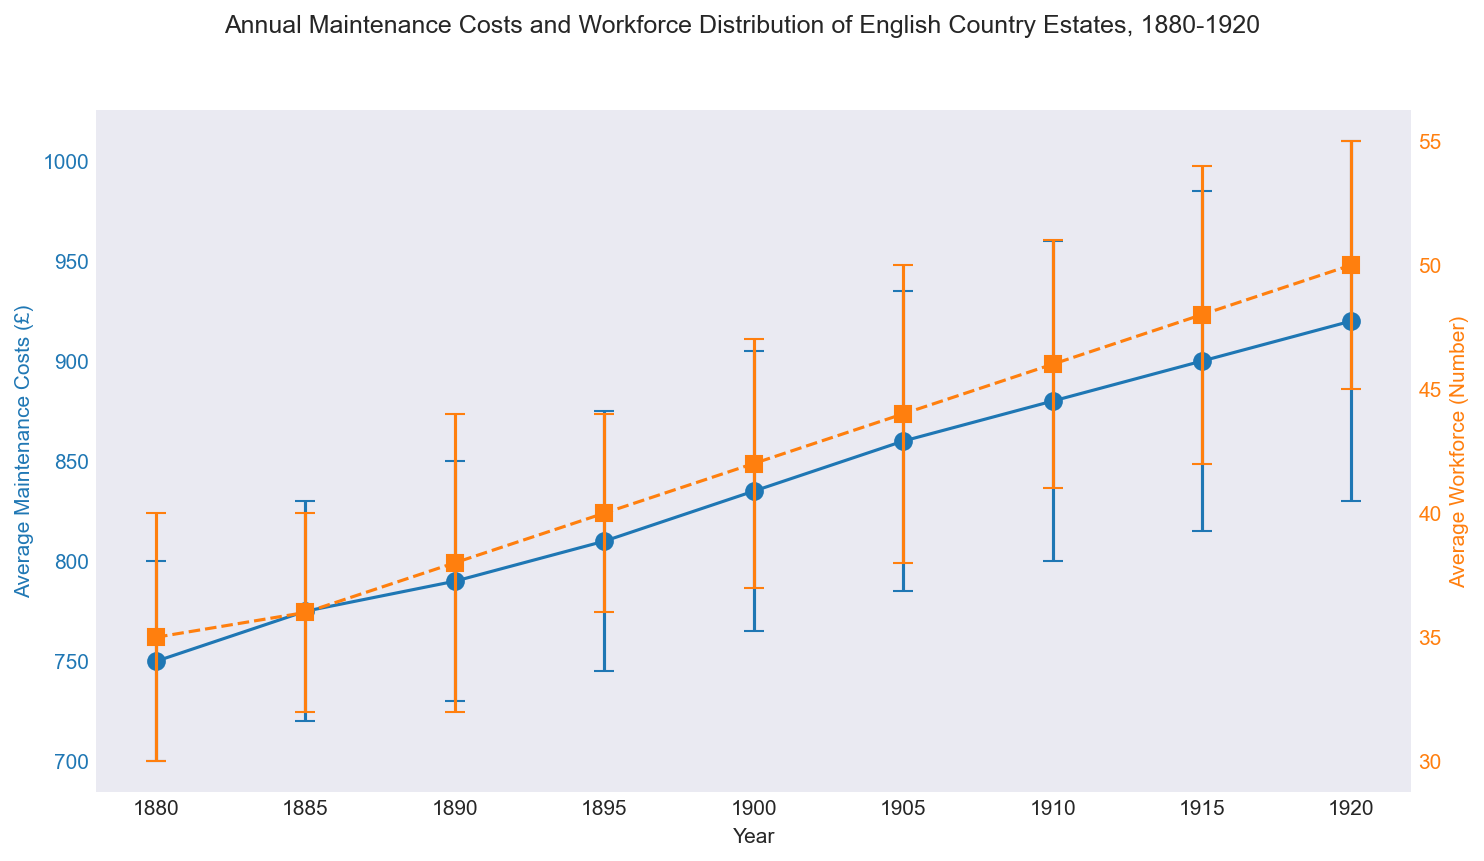What is the trend in the average maintenance costs of English country estates from 1880 to 1920? The average maintenance costs increase over time from £750 in 1880 to £920 in 1920.
Answer: They increase Between which years does the average workforce see the highest increase? The average workforce sees the highest increase between 1915 and 1920, from 48 to 50.
Answer: 1915 to 1920 What is the average of the average maintenance costs over the period 1880-1920? Adding the average maintenance costs from 1880 to 1920: (750 + 775 + 790 + 810 + 835 + 860 + 880 + 900 + 920) = 7520. Divide by the number of years (9) to get 7520/9 ≈ 835.56.
Answer: Approx 835.56 How does the error margin for maintenance costs change over the years? The error margin for maintenance costs gradually increases from £50 in 1880 to £90 in 1920.
Answer: It increases What is the difference between the highest and lowest average workforce over the period? The highest average workforce is 50 in 1920 and the lowest is 35 in 1880. The difference is 50 - 35 = 15.
Answer: 15 In which year is the average maintenance cost the closest to £800? The closest average maintenance cost to £800 is in 1895 (£810).
Answer: 1895 Compare the increase in error margins for maintenance costs and workforce between 1880 and 1920. Which one has a greater increase? The error margin for maintenance costs increases from £50 to £90 (40), and for workforce it increases from 5 to 5 (0). The error margin for maintenance costs has a greater increase.
Answer: Maintenance costs Between 1910 and 1915, how much do the average maintenance costs increase? The average maintenance costs increase from £880 in 1910 to £900 in 1915, an increase of £20.
Answer: £20 Which year has the highest average workforce, and what is the value? The year 1920 has the highest average workforce of 50.
Answer: 1920 In which year did the error margin for workforce show the highest value, and what is that value? The error margin for workforce is highest in two years: 1890 and 1915, both at 6.
Answer: 1890 and 1915 